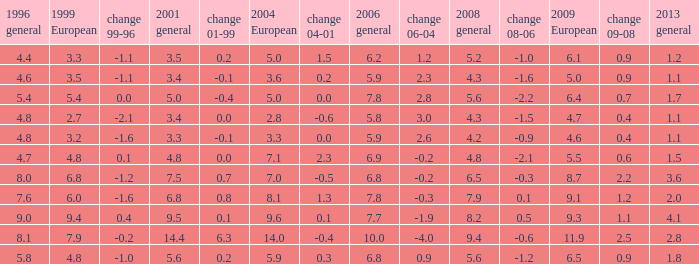What was the value for 2004 European with less than 7.5 in general 2001, less than 6.4 in 2009 European, and less than 1.5 in general 2013 with 4.3 in 2008 general? 3.6, 2.8. 